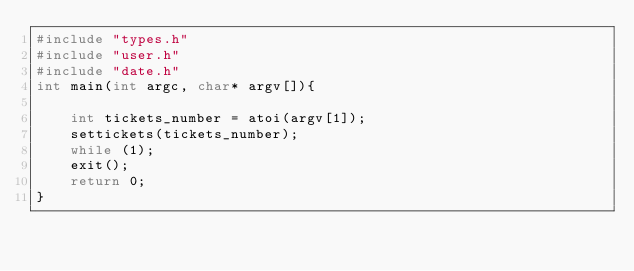<code> <loc_0><loc_0><loc_500><loc_500><_C_>#include "types.h"
#include "user.h"
#include "date.h"
int main(int argc, char* argv[]){
    
    int tickets_number = atoi(argv[1]);
    settickets(tickets_number);
    while (1);
    exit();
    return 0;
}

</code> 